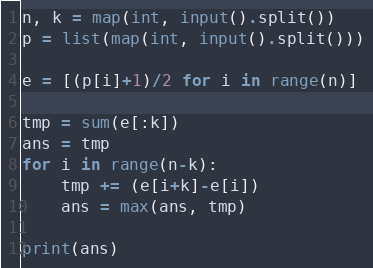<code> <loc_0><loc_0><loc_500><loc_500><_Python_>n, k = map(int, input().split())
p = list(map(int, input().split()))

e = [(p[i]+1)/2 for i in range(n)]

tmp = sum(e[:k])
ans = tmp
for i in range(n-k):
    tmp += (e[i+k]-e[i])
    ans = max(ans, tmp)

print(ans)</code> 